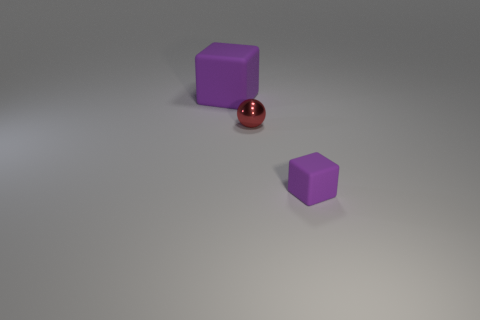Add 3 purple objects. How many objects exist? 6 Subtract all blocks. How many objects are left? 1 Add 2 small cyan shiny cubes. How many small cyan shiny cubes exist? 2 Subtract 0 blue cylinders. How many objects are left? 3 Subtract all tiny green rubber cylinders. Subtract all red metal balls. How many objects are left? 2 Add 3 tiny purple matte blocks. How many tiny purple matte blocks are left? 4 